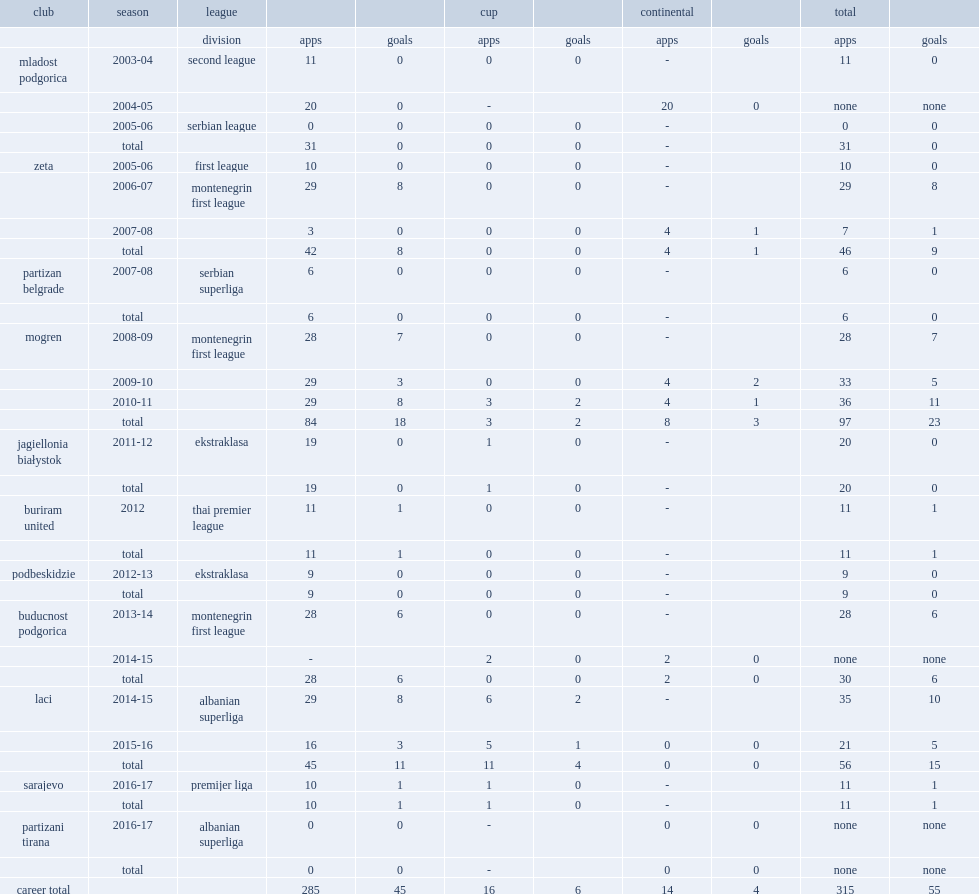Which club did cetkovic play for in 2016-17? Partizani tirana. 